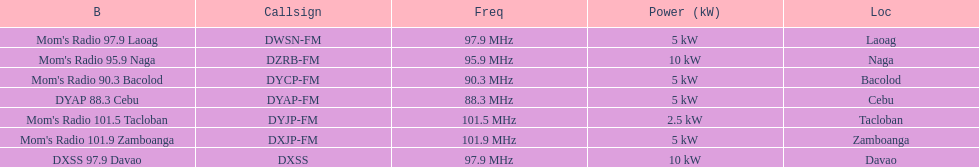What is the difference in kw between naga and bacolod radio? 5 kW. 